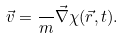<formula> <loc_0><loc_0><loc_500><loc_500>\vec { v } = \frac { } { m } \vec { \nabla } \chi ( \vec { r } , t ) .</formula> 